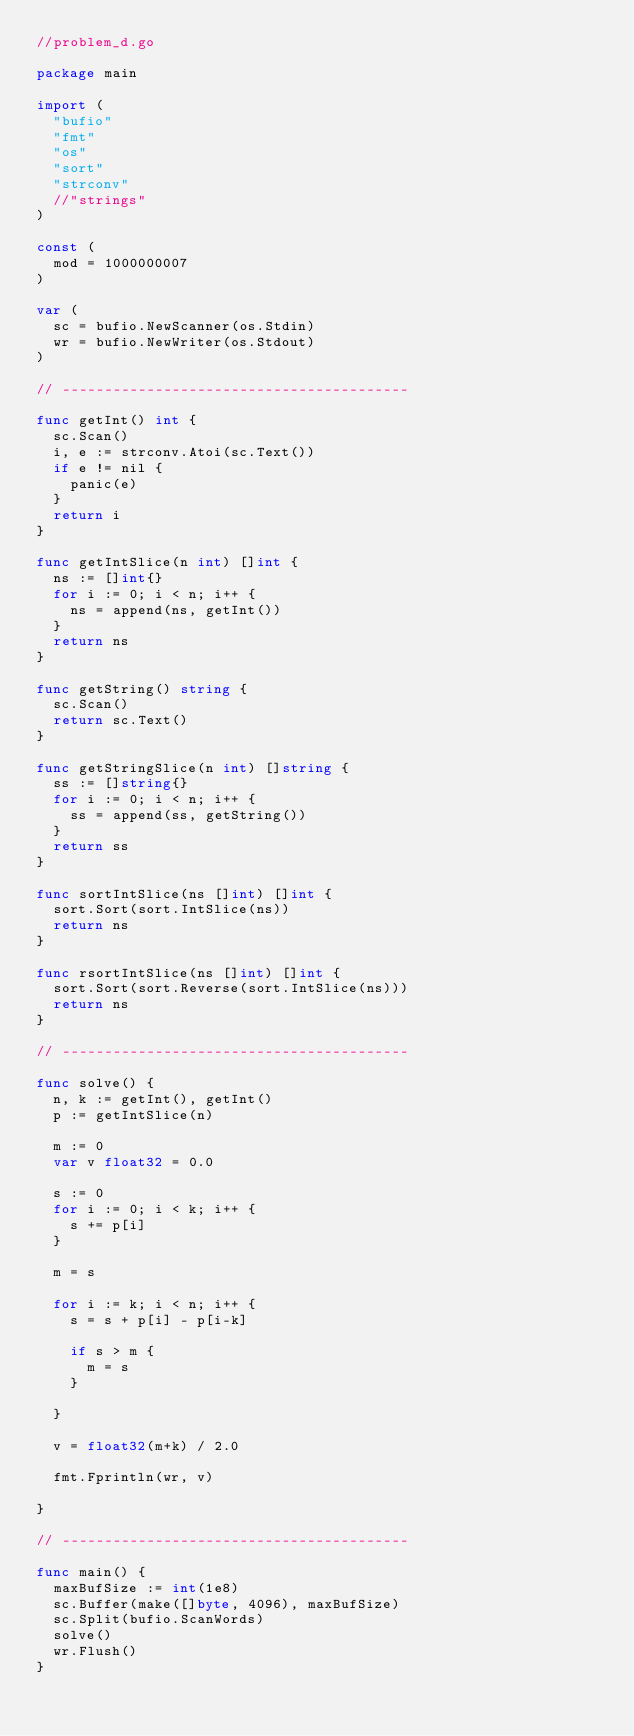<code> <loc_0><loc_0><loc_500><loc_500><_Go_>//problem_d.go

package main

import (
	"bufio"
	"fmt"
	"os"
	"sort"
	"strconv"
	//"strings"
)

const (
	mod = 1000000007
)

var (
	sc = bufio.NewScanner(os.Stdin)
	wr = bufio.NewWriter(os.Stdout)
)

// -----------------------------------------

func getInt() int {
	sc.Scan()
	i, e := strconv.Atoi(sc.Text())
	if e != nil {
		panic(e)
	}
	return i
}

func getIntSlice(n int) []int {
	ns := []int{}
	for i := 0; i < n; i++ {
		ns = append(ns, getInt())
	}
	return ns
}

func getString() string {
	sc.Scan()
	return sc.Text()
}

func getStringSlice(n int) []string {
	ss := []string{}
	for i := 0; i < n; i++ {
		ss = append(ss, getString())
	}
	return ss
}

func sortIntSlice(ns []int) []int {
	sort.Sort(sort.IntSlice(ns))
	return ns
}

func rsortIntSlice(ns []int) []int {
	sort.Sort(sort.Reverse(sort.IntSlice(ns)))
	return ns
}

// -----------------------------------------

func solve() {
	n, k := getInt(), getInt()
	p := getIntSlice(n)

	m := 0
	var v float32 = 0.0

	s := 0
	for i := 0; i < k; i++ {
		s += p[i]
	}

	m = s

	for i := k; i < n; i++ {
		s = s + p[i] - p[i-k]

		if s > m {
			m = s
		}

	}

	v = float32(m+k) / 2.0

	fmt.Fprintln(wr, v)

}

// -----------------------------------------

func main() {
	maxBufSize := int(1e8)
	sc.Buffer(make([]byte, 4096), maxBufSize)
	sc.Split(bufio.ScanWords)
	solve()
	wr.Flush()
}
</code> 